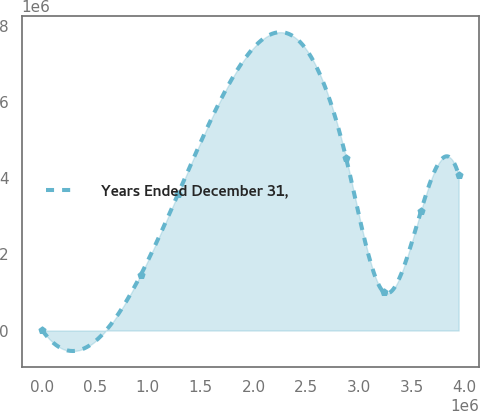Convert chart to OTSL. <chart><loc_0><loc_0><loc_500><loc_500><line_chart><ecel><fcel>Years Ended December 31,<nl><fcel>1787.77<fcel>1801.43<nl><fcel>931373<fcel>1.45028e+06<nl><fcel>1.28652e+06<fcel>3.58708e+06<nl><fcel>2.87672e+06<fcel>4.53073e+06<nl><fcel>3.23186e+06<fcel>1.01322e+06<nl><fcel>3.587e+06<fcel>3.15002e+06<nl><fcel>3.94215e+06<fcel>4.09367e+06<nl></chart> 